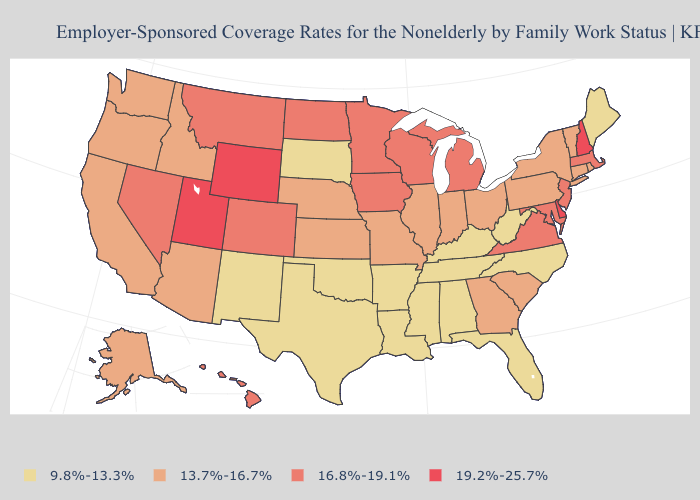Does Virginia have a lower value than Utah?
Be succinct. Yes. Does Nevada have a lower value than New York?
Write a very short answer. No. What is the value of Arizona?
Concise answer only. 13.7%-16.7%. Which states have the highest value in the USA?
Give a very brief answer. Delaware, New Hampshire, Utah, Wyoming. Does Alabama have the lowest value in the USA?
Keep it brief. Yes. Does Massachusetts have the same value as New Mexico?
Be succinct. No. Does the map have missing data?
Concise answer only. No. Among the states that border Rhode Island , which have the lowest value?
Concise answer only. Connecticut. Does the first symbol in the legend represent the smallest category?
Be succinct. Yes. What is the value of Virginia?
Be succinct. 16.8%-19.1%. What is the value of New Mexico?
Keep it brief. 9.8%-13.3%. Does Kansas have the lowest value in the MidWest?
Write a very short answer. No. Name the states that have a value in the range 13.7%-16.7%?
Quick response, please. Alaska, Arizona, California, Connecticut, Georgia, Idaho, Illinois, Indiana, Kansas, Missouri, Nebraska, New York, Ohio, Oregon, Pennsylvania, Rhode Island, South Carolina, Vermont, Washington. What is the value of Virginia?
Be succinct. 16.8%-19.1%. Does New York have the highest value in the Northeast?
Give a very brief answer. No. 